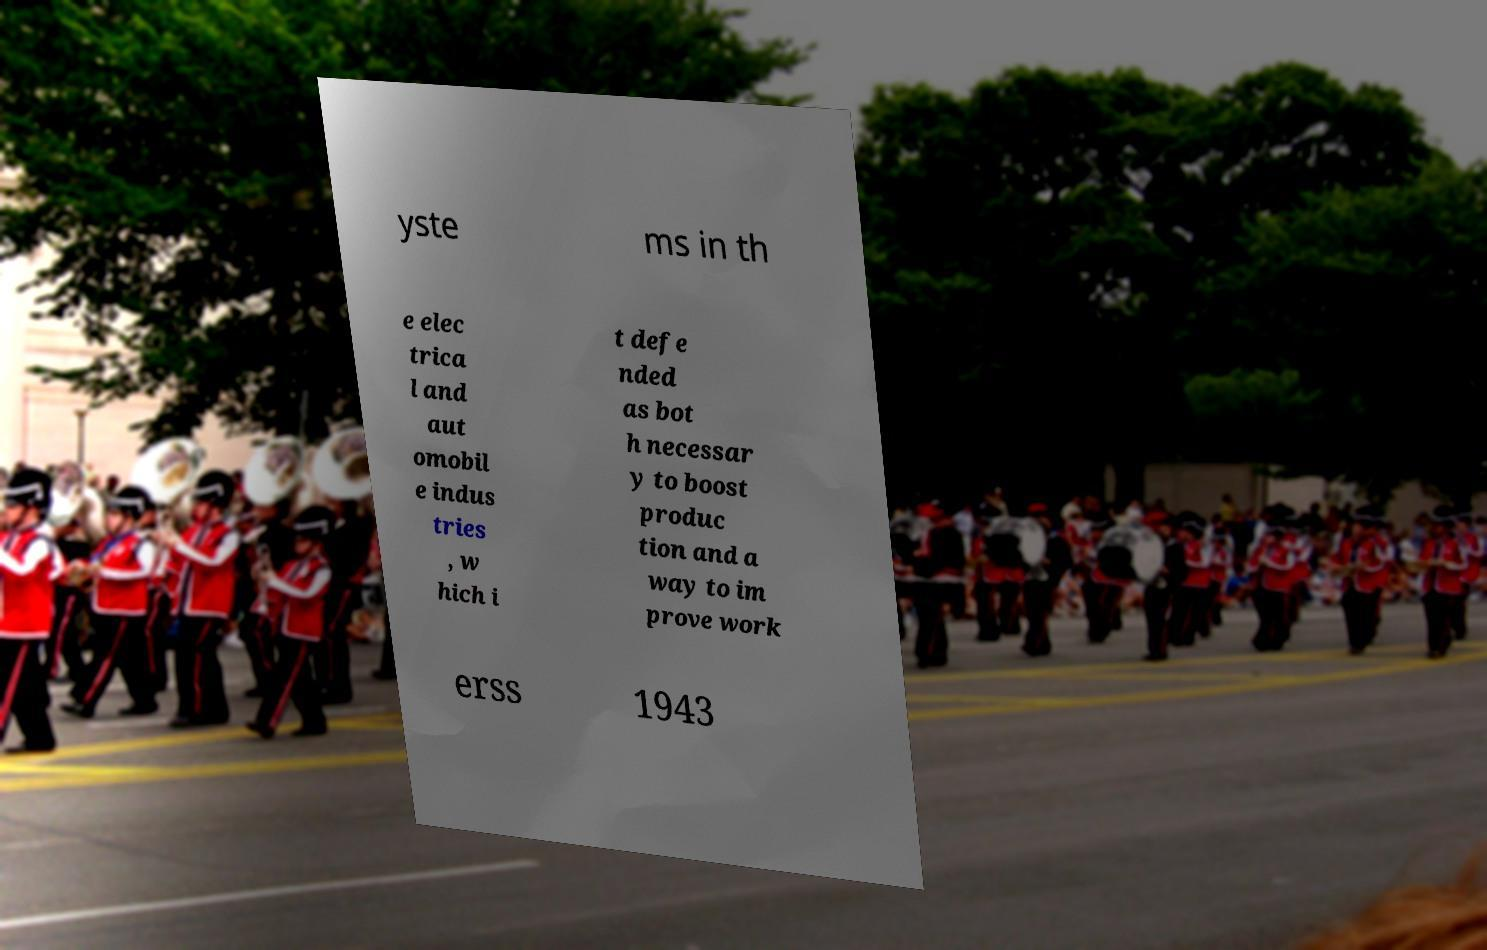Please identify and transcribe the text found in this image. yste ms in th e elec trica l and aut omobil e indus tries , w hich i t defe nded as bot h necessar y to boost produc tion and a way to im prove work erss 1943 